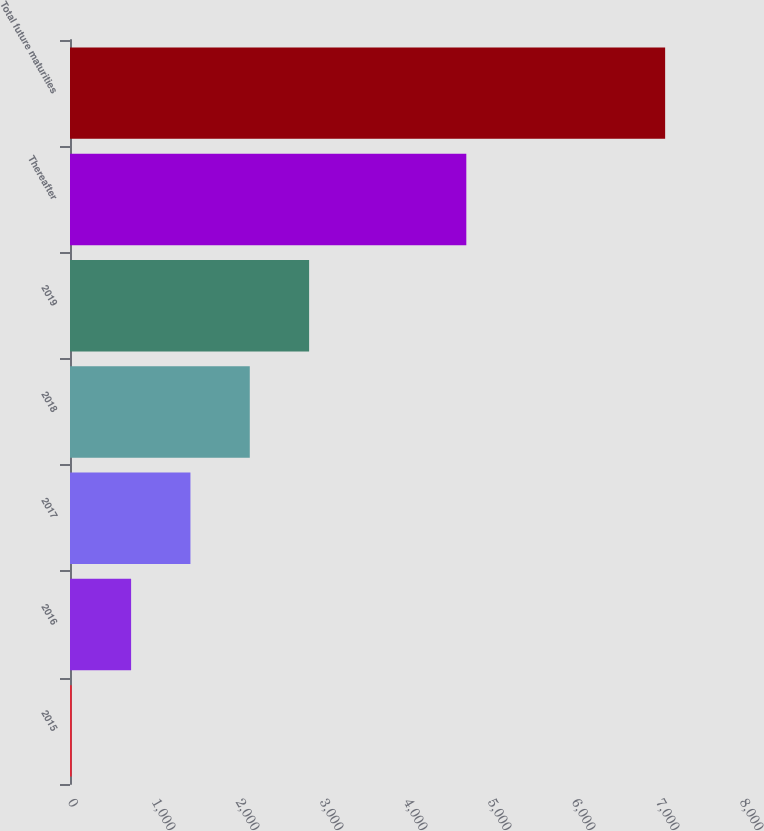Convert chart. <chart><loc_0><loc_0><loc_500><loc_500><bar_chart><fcel>2015<fcel>2016<fcel>2017<fcel>2018<fcel>2019<fcel>Thereafter<fcel>Total future maturities<nl><fcel>21<fcel>727.4<fcel>1433.8<fcel>2140.2<fcel>2846.6<fcel>4718<fcel>7085<nl></chart> 